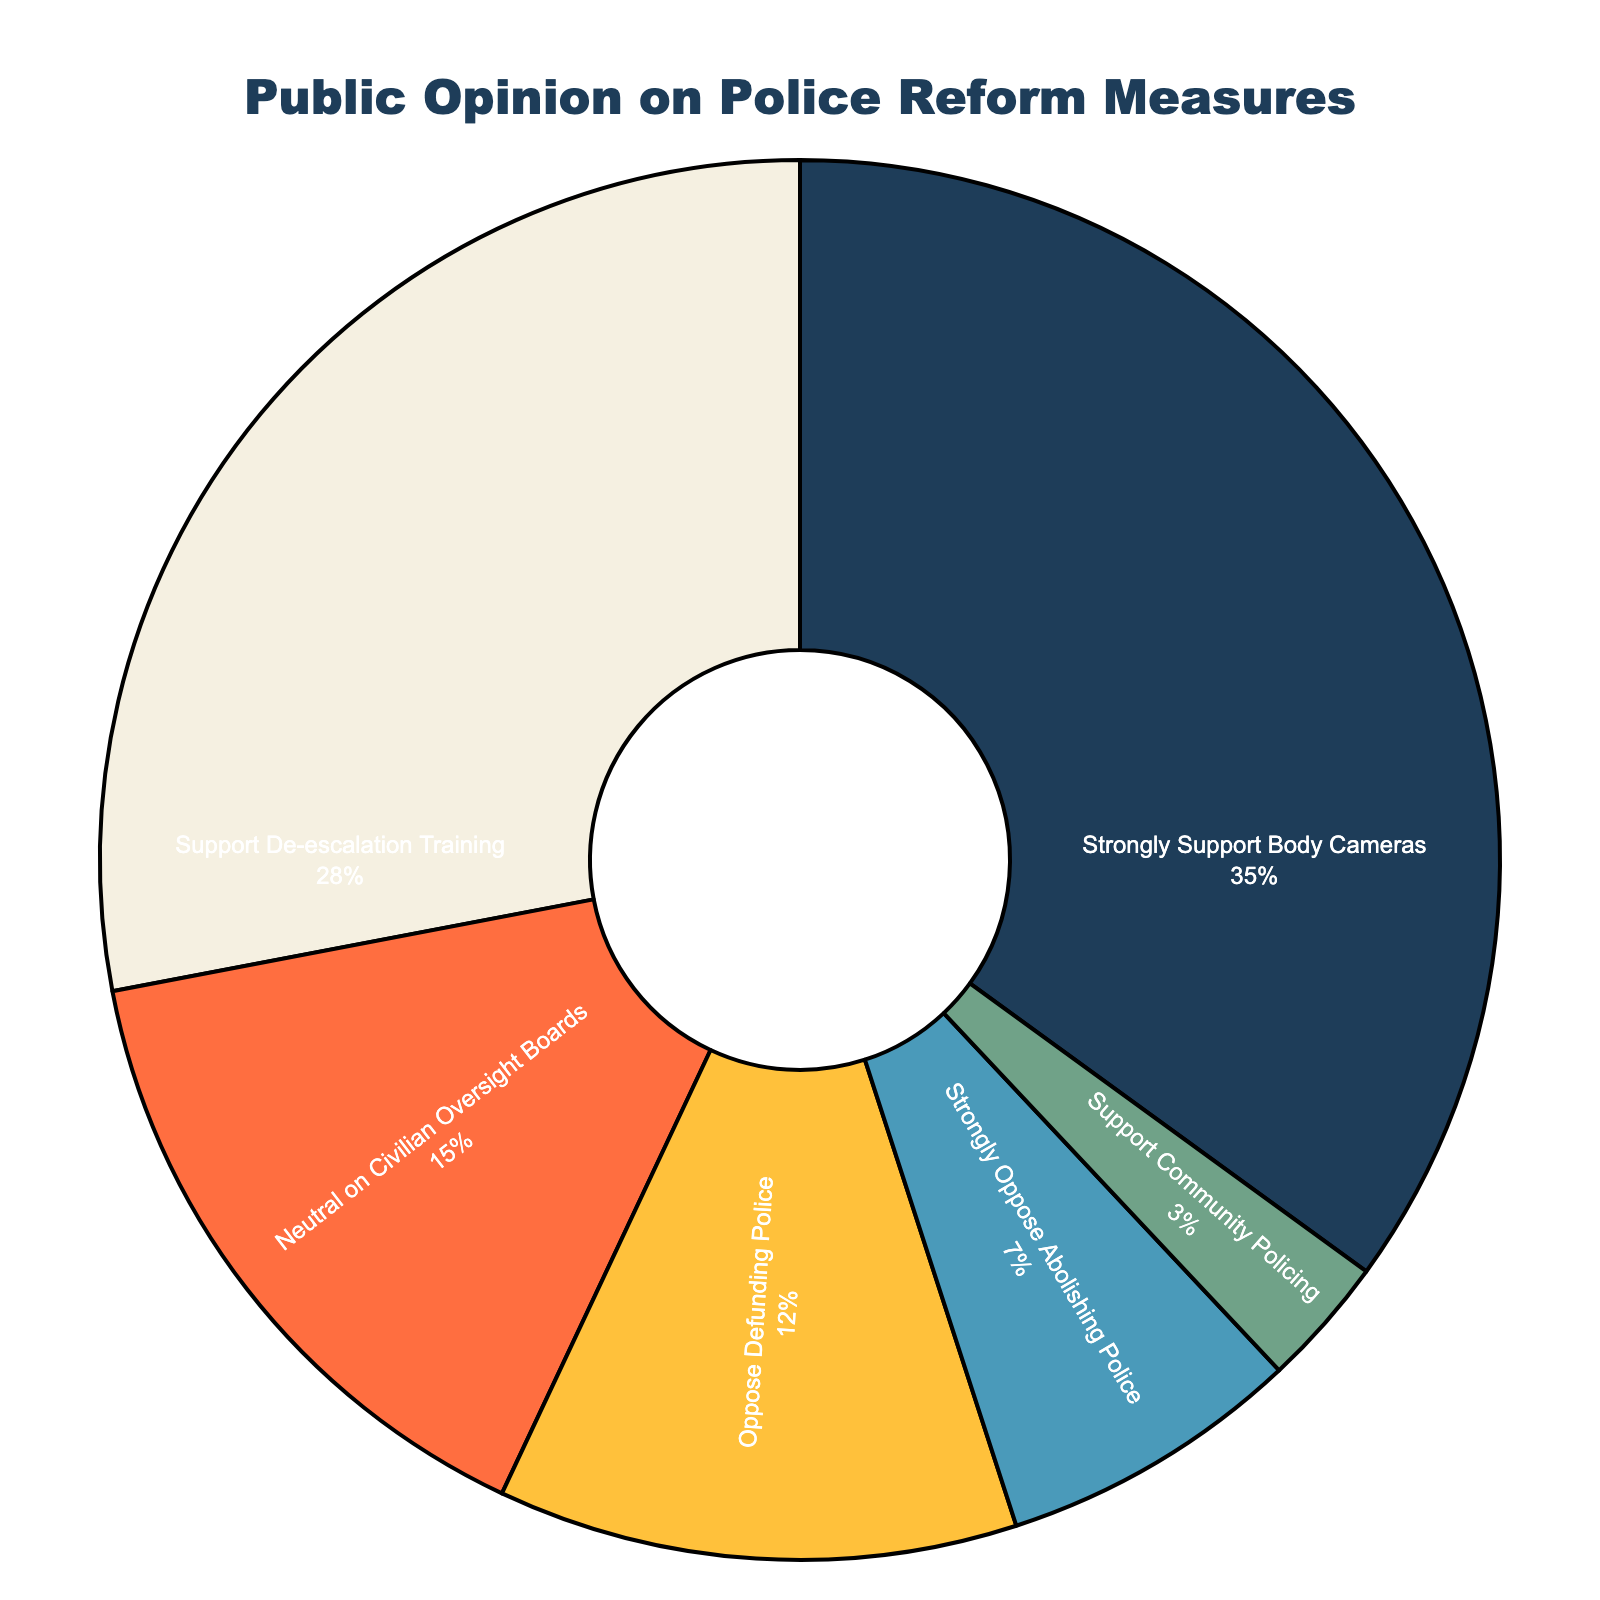What percentage of people strongly support body cameras? Check the section of the pie chart labeled "Strongly Support Body Cameras" and note its percentage.
Answer: 35% What is the combined percentage of people who support de-escalation training and community policing? Sum the percentages of "Support De-escalation Training" (28%) and "Support Community Policing" (3%): 28 + 3 = 31
Answer: 31% What is the difference in percentage between those who strongly support body cameras and those who oppose defunding police? Subtract the percentage of "Oppose Defunding Police" (12%) from "Strongly Support Body Cameras" (35%): 35 - 12 = 23
Answer: 23% Which measure has the smallest support percentage, and what is that percentage? Check the percentages of all categories and find the smallest one, which is "Support Community Policing" at 3%.
Answer: Support Community Policing, 3% What is the total percentage of people who are neutral or oppose police reform measures? Sum the percentages of "Neutral on Civilian Oversight Boards" (15%), "Oppose Defunding Police" (12%), and "Strongly Oppose Abolishing Police" (7%): 15 + 12 + 7 = 34
Answer: 34% Is the percentage of people who support de-escalation training higher than the percentage of people neutral on civilian oversight boards? Compare the percentage of "Support De-escalation Training" (28%) with "Neutral on Civilian Oversight Boards" (15%): 28 > 15.
Answer: Yes Which section of the pie chart is highlighted using the darkest color, and what measure does it represent? Identify the section with the darkest shade, which is "Strongly Support Body Cameras" with the darkest blue color.
Answer: Strongly Support Body Cameras How much higher is the percentage for people opposing defunding the police compared to those supporting community policing? Subtract the percentage for "Support Community Policing" (3%) from "Oppose Defunding Police" (12%): 12 - 3 = 9
Answer: 9% What measure has the second highest percentage of support? Check the percentages of all measures and find the one with the second highest value after "Strongly Support Body Cameras" (35%), which is "Support De-escalation Training" at 28%.
Answer: Support De-escalation Training Does the "Strongly Oppose Abolishing Police" section appear larger or smaller than "Support Community Policing"? Visually compare the sizes of "Strongly Oppose Abolishing Police" and "Support Community Policing" sections, noting that the former (7%) is larger than the latter (3%).
Answer: Larger 